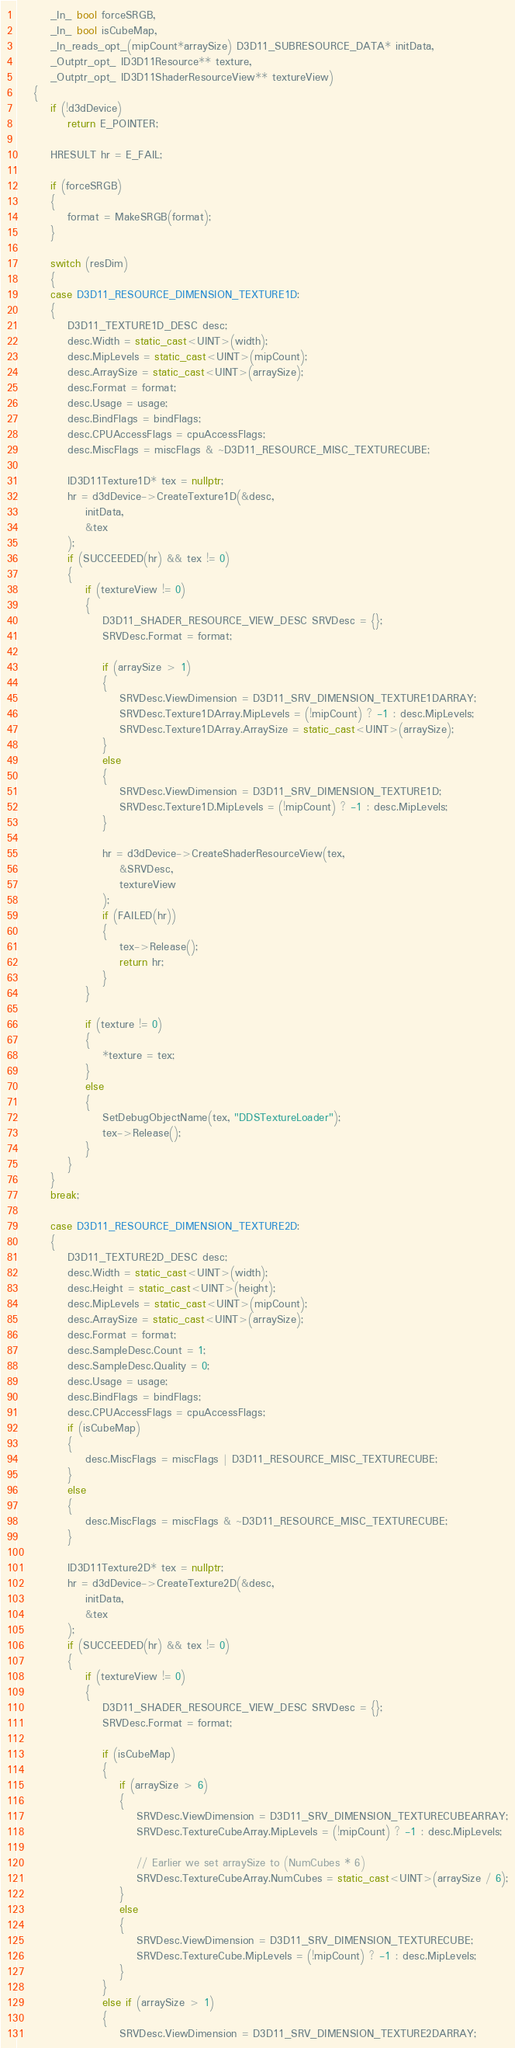<code> <loc_0><loc_0><loc_500><loc_500><_C++_>        _In_ bool forceSRGB,
        _In_ bool isCubeMap,
        _In_reads_opt_(mipCount*arraySize) D3D11_SUBRESOURCE_DATA* initData,
        _Outptr_opt_ ID3D11Resource** texture,
        _Outptr_opt_ ID3D11ShaderResourceView** textureView)
    {
        if (!d3dDevice)
            return E_POINTER;

        HRESULT hr = E_FAIL;

        if (forceSRGB)
        {
            format = MakeSRGB(format);
        }

        switch (resDim)
        {
        case D3D11_RESOURCE_DIMENSION_TEXTURE1D:
        {
            D3D11_TEXTURE1D_DESC desc;
            desc.Width = static_cast<UINT>(width);
            desc.MipLevels = static_cast<UINT>(mipCount);
            desc.ArraySize = static_cast<UINT>(arraySize);
            desc.Format = format;
            desc.Usage = usage;
            desc.BindFlags = bindFlags;
            desc.CPUAccessFlags = cpuAccessFlags;
            desc.MiscFlags = miscFlags & ~D3D11_RESOURCE_MISC_TEXTURECUBE;

            ID3D11Texture1D* tex = nullptr;
            hr = d3dDevice->CreateTexture1D(&desc,
                initData,
                &tex
            );
            if (SUCCEEDED(hr) && tex != 0)
            {
                if (textureView != 0)
                {
                    D3D11_SHADER_RESOURCE_VIEW_DESC SRVDesc = {};
                    SRVDesc.Format = format;

                    if (arraySize > 1)
                    {
                        SRVDesc.ViewDimension = D3D11_SRV_DIMENSION_TEXTURE1DARRAY;
                        SRVDesc.Texture1DArray.MipLevels = (!mipCount) ? -1 : desc.MipLevels;
                        SRVDesc.Texture1DArray.ArraySize = static_cast<UINT>(arraySize);
                    }
                    else
                    {
                        SRVDesc.ViewDimension = D3D11_SRV_DIMENSION_TEXTURE1D;
                        SRVDesc.Texture1D.MipLevels = (!mipCount) ? -1 : desc.MipLevels;
                    }

                    hr = d3dDevice->CreateShaderResourceView(tex,
                        &SRVDesc,
                        textureView
                    );
                    if (FAILED(hr))
                    {
                        tex->Release();
                        return hr;
                    }
                }

                if (texture != 0)
                {
                    *texture = tex;
                }
                else
                {
                    SetDebugObjectName(tex, "DDSTextureLoader");
                    tex->Release();
                }
            }
        }
        break;

        case D3D11_RESOURCE_DIMENSION_TEXTURE2D:
        {
            D3D11_TEXTURE2D_DESC desc;
            desc.Width = static_cast<UINT>(width);
            desc.Height = static_cast<UINT>(height);
            desc.MipLevels = static_cast<UINT>(mipCount);
            desc.ArraySize = static_cast<UINT>(arraySize);
            desc.Format = format;
            desc.SampleDesc.Count = 1;
            desc.SampleDesc.Quality = 0;
            desc.Usage = usage;
            desc.BindFlags = bindFlags;
            desc.CPUAccessFlags = cpuAccessFlags;
            if (isCubeMap)
            {
                desc.MiscFlags = miscFlags | D3D11_RESOURCE_MISC_TEXTURECUBE;
            }
            else
            {
                desc.MiscFlags = miscFlags & ~D3D11_RESOURCE_MISC_TEXTURECUBE;
            }

            ID3D11Texture2D* tex = nullptr;
            hr = d3dDevice->CreateTexture2D(&desc,
                initData,
                &tex
            );
            if (SUCCEEDED(hr) && tex != 0)
            {
                if (textureView != 0)
                {
                    D3D11_SHADER_RESOURCE_VIEW_DESC SRVDesc = {};
                    SRVDesc.Format = format;

                    if (isCubeMap)
                    {
                        if (arraySize > 6)
                        {
                            SRVDesc.ViewDimension = D3D11_SRV_DIMENSION_TEXTURECUBEARRAY;
                            SRVDesc.TextureCubeArray.MipLevels = (!mipCount) ? -1 : desc.MipLevels;

                            // Earlier we set arraySize to (NumCubes * 6)
                            SRVDesc.TextureCubeArray.NumCubes = static_cast<UINT>(arraySize / 6);
                        }
                        else
                        {
                            SRVDesc.ViewDimension = D3D11_SRV_DIMENSION_TEXTURECUBE;
                            SRVDesc.TextureCube.MipLevels = (!mipCount) ? -1 : desc.MipLevels;
                        }
                    }
                    else if (arraySize > 1)
                    {
                        SRVDesc.ViewDimension = D3D11_SRV_DIMENSION_TEXTURE2DARRAY;</code> 